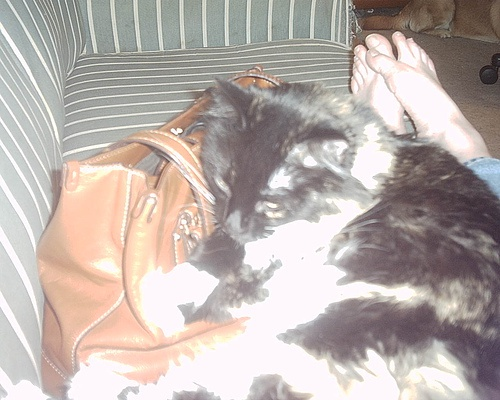Describe the objects in this image and their specific colors. I can see cat in darkgray, white, and gray tones, couch in darkgray, lightgray, and gray tones, handbag in darkgray, tan, and ivory tones, people in darkgray, white, gray, and lightgray tones, and dog in darkgray, gray, and maroon tones in this image. 